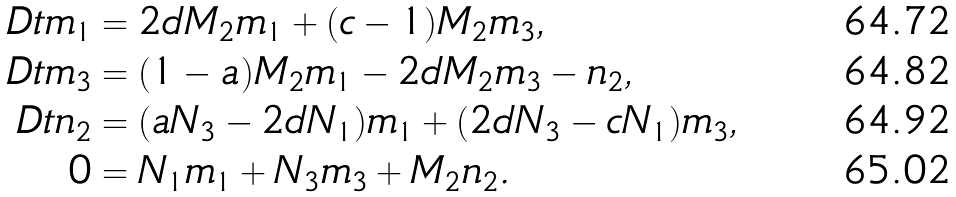<formula> <loc_0><loc_0><loc_500><loc_500>\ D t m _ { 1 } & = 2 d M _ { 2 } m _ { 1 } + ( c - 1 ) M _ { 2 } m _ { 3 } , \\ \ D t m _ { 3 } & = ( 1 - a ) M _ { 2 } m _ { 1 } - 2 d M _ { 2 } m _ { 3 } - n _ { 2 } , \\ \ D t n _ { 2 } & = ( a N _ { 3 } - 2 d N _ { 1 } ) m _ { 1 } + ( 2 d N _ { 3 } - c N _ { 1 } ) m _ { 3 } , \\ 0 & = N _ { 1 } m _ { 1 } + N _ { 3 } m _ { 3 } + M _ { 2 } n _ { 2 } .</formula> 